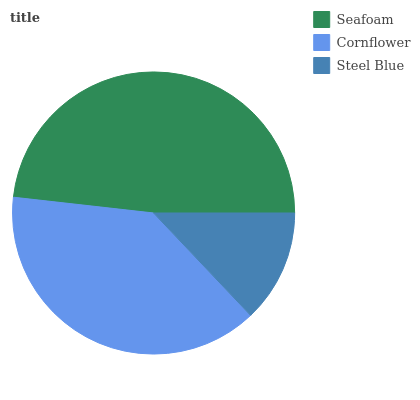Is Steel Blue the minimum?
Answer yes or no. Yes. Is Seafoam the maximum?
Answer yes or no. Yes. Is Cornflower the minimum?
Answer yes or no. No. Is Cornflower the maximum?
Answer yes or no. No. Is Seafoam greater than Cornflower?
Answer yes or no. Yes. Is Cornflower less than Seafoam?
Answer yes or no. Yes. Is Cornflower greater than Seafoam?
Answer yes or no. No. Is Seafoam less than Cornflower?
Answer yes or no. No. Is Cornflower the high median?
Answer yes or no. Yes. Is Cornflower the low median?
Answer yes or no. Yes. Is Steel Blue the high median?
Answer yes or no. No. Is Seafoam the low median?
Answer yes or no. No. 